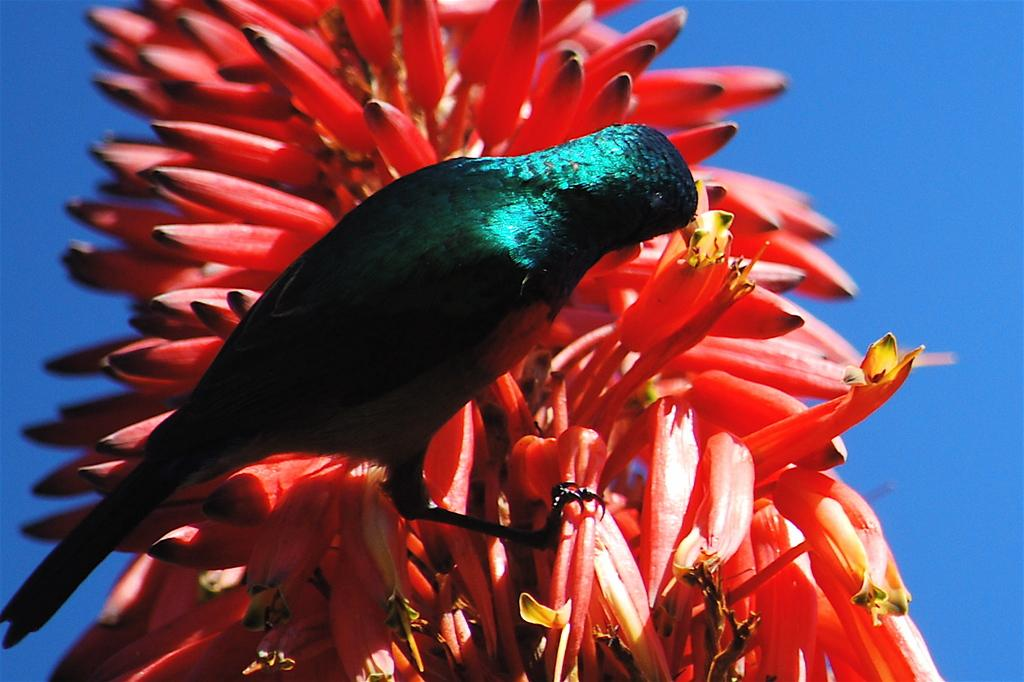What type of animal is in the image? There is a bird in the image. Where is the bird located? The bird is sitting on a plant. What color are the flowers on the plant? The flowers on the plant are red in color. What can be seen in the background of the image? The sky is visible in the background of the image. What is the color of the sky in the image? The sky is blue in color. What type of pancake is the bird eating in the image? There is no pancake present in the image, and the bird is not eating anything. How many shoes can be seen in the image? There are no shoes present in the image. 